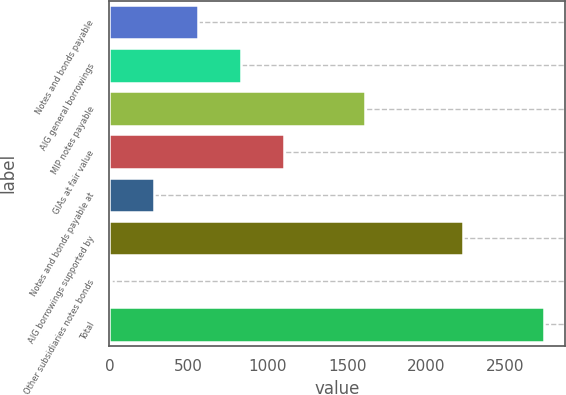Convert chart. <chart><loc_0><loc_0><loc_500><loc_500><bar_chart><fcel>Notes and bonds payable<fcel>AIG general borrowings<fcel>MIP notes payable<fcel>GIAs at fair value<fcel>Notes and bonds payable at<fcel>AIG borrowings supported by<fcel>Other subsidiaries notes bonds<fcel>Total<nl><fcel>556.8<fcel>829.7<fcel>1613<fcel>1102.6<fcel>283.9<fcel>2229<fcel>11<fcel>2740<nl></chart> 